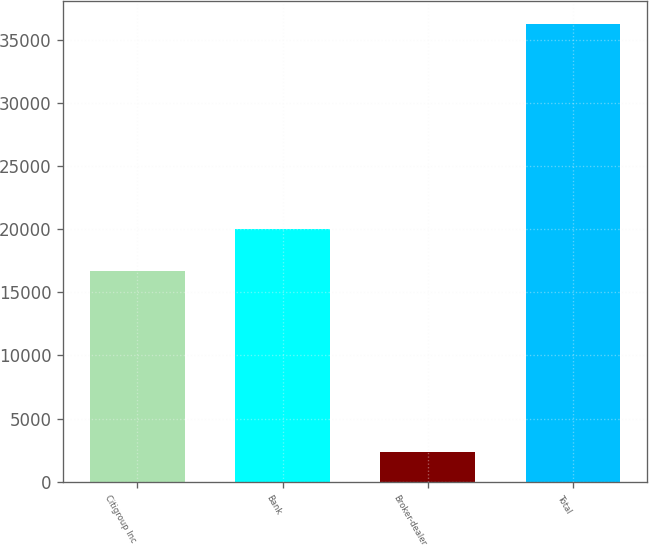Convert chart. <chart><loc_0><loc_0><loc_500><loc_500><bar_chart><fcel>Citigroup Inc<fcel>Bank<fcel>Broker-dealer<fcel>Total<nl><fcel>16656<fcel>20046.1<fcel>2388<fcel>36289<nl></chart> 